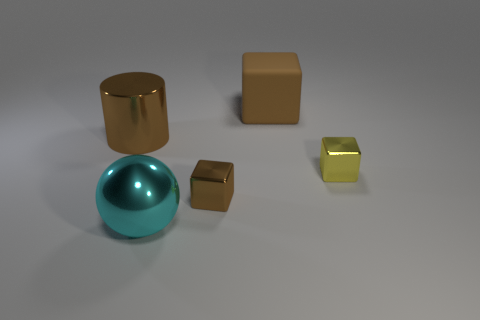Are there any other things that have the same material as the large cube?
Your response must be concise. No. How many other things are the same color as the large shiny ball?
Ensure brevity in your answer.  0. How big is the cyan metallic thing?
Ensure brevity in your answer.  Large. Is there a blue cube?
Offer a very short reply. No. Is the number of brown metal cylinders that are behind the large brown metallic cylinder greater than the number of big cubes behind the brown rubber thing?
Provide a succinct answer. No. The block that is both in front of the large metallic cylinder and left of the tiny yellow block is made of what material?
Your response must be concise. Metal. Is the shape of the matte thing the same as the large brown metallic object?
Your answer should be very brief. No. Is there anything else that has the same size as the brown cylinder?
Keep it short and to the point. Yes. How many brown metal things are on the right side of the big cyan metal object?
Your answer should be compact. 1. Do the brown metal object that is left of the cyan shiny ball and the big rubber block have the same size?
Offer a very short reply. Yes. 